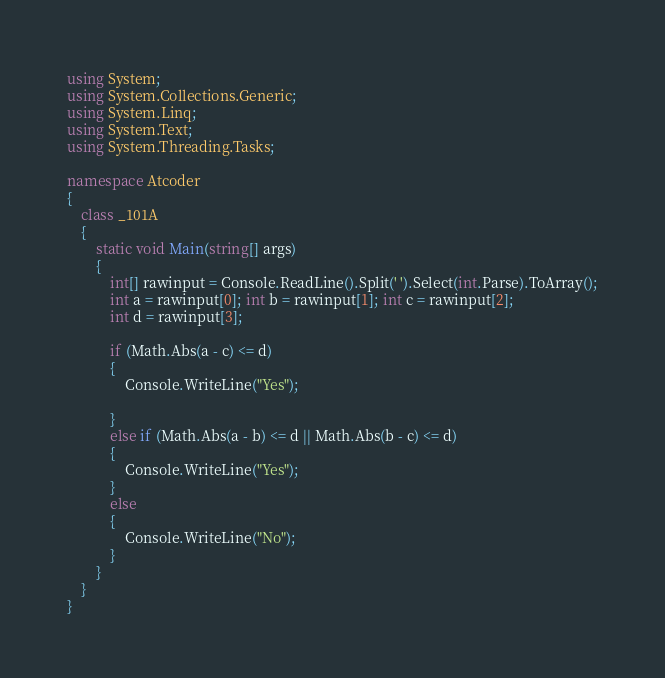<code> <loc_0><loc_0><loc_500><loc_500><_C#_>using System;
using System.Collections.Generic;
using System.Linq;
using System.Text;
using System.Threading.Tasks;

namespace Atcoder
{
    class _101A
    {
        static void Main(string[] args)
        {
            int[] rawinput = Console.ReadLine().Split(' ').Select(int.Parse).ToArray();
            int a = rawinput[0]; int b = rawinput[1]; int c = rawinput[2];
            int d = rawinput[3];
            
            if (Math.Abs(a - c) <= d)
            {
                Console.WriteLine("Yes");
                
            }
            else if (Math.Abs(a - b) <= d || Math.Abs(b - c) <= d)
            {
                Console.WriteLine("Yes");
            }
            else
            {
                Console.WriteLine("No");
            }
        }
    }
}
</code> 